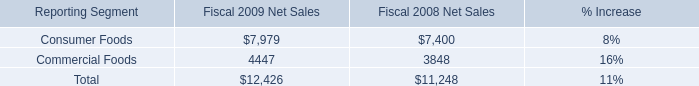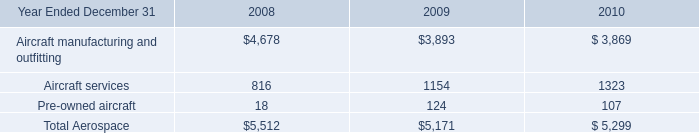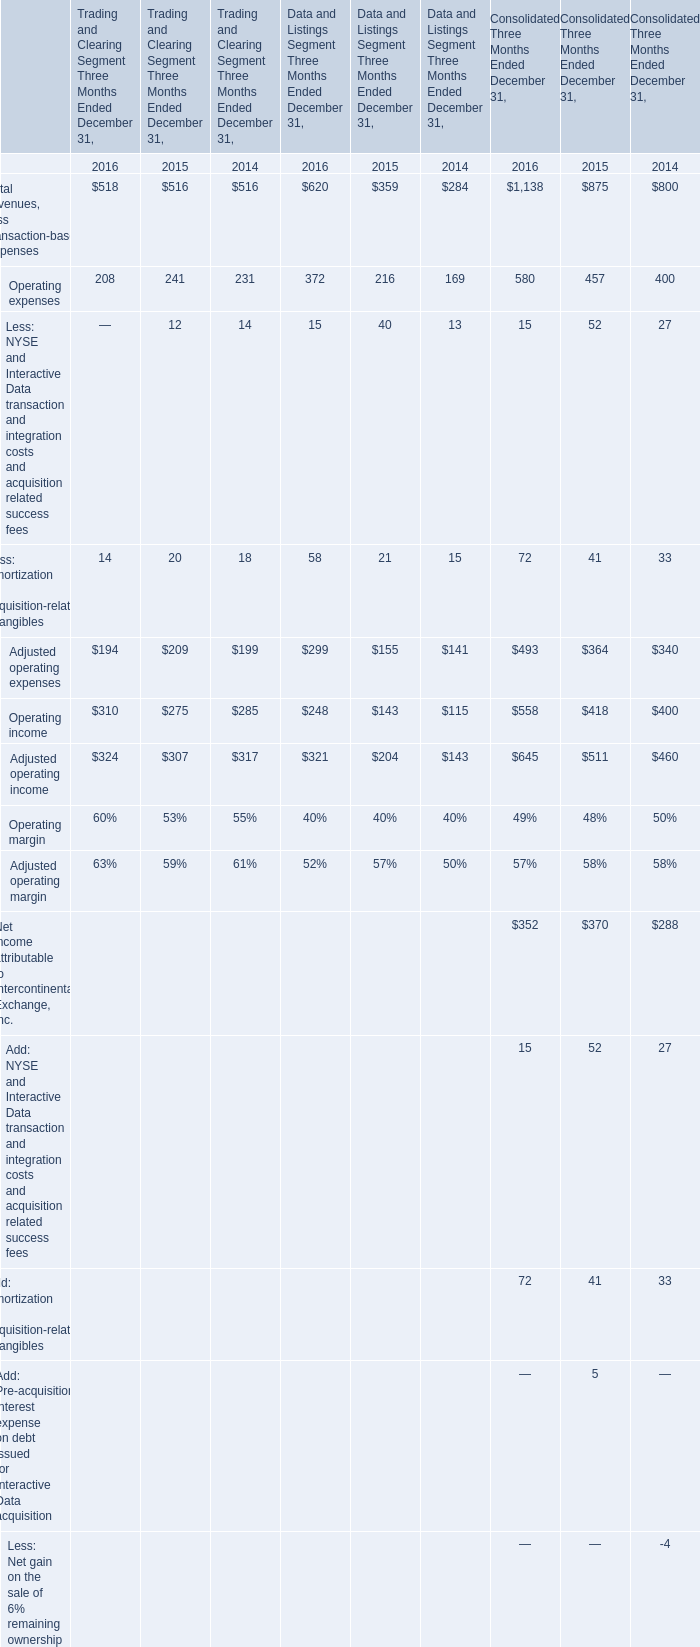Which year section is Operating income for Trading and Clearing Segment Three Months Ended December 31 the highest? 
Answer: 2016. In the year with largest amount of Operating income for Trading and Clearing Segment Three Months Ended December 31, what's the sum of Adjusted operating expenses? 
Computations: ((194 + 299) + 493)
Answer: 986.0. 